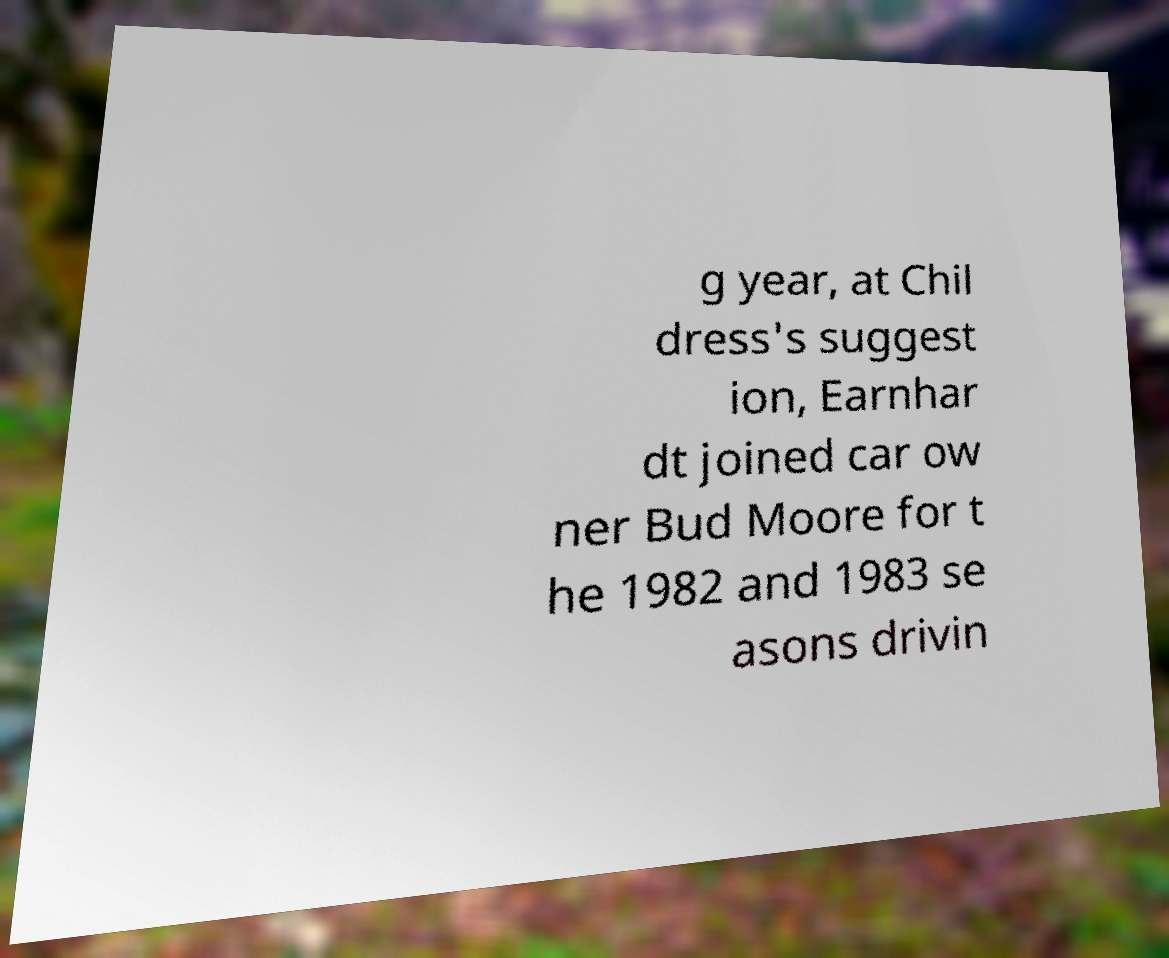Please identify and transcribe the text found in this image. g year, at Chil dress's suggest ion, Earnhar dt joined car ow ner Bud Moore for t he 1982 and 1983 se asons drivin 